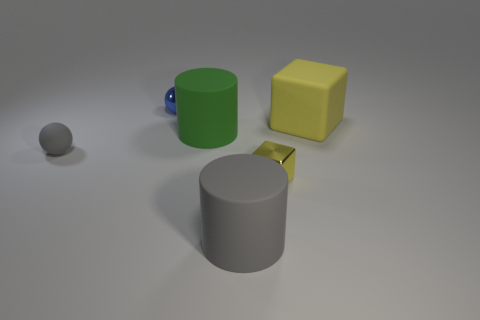Does the gray thing in front of the small block have the same material as the cylinder that is behind the small gray object?
Provide a short and direct response. Yes. There is a big thing that is the same color as the rubber sphere; what is its shape?
Your answer should be very brief. Cylinder. What number of objects are yellow shiny blocks that are to the left of the matte block or matte objects behind the gray sphere?
Your response must be concise. 3. There is a ball in front of the big green rubber cylinder; does it have the same color as the rubber thing in front of the small rubber sphere?
Offer a terse response. Yes. There is a thing that is both on the right side of the gray matte cylinder and in front of the matte ball; what is its shape?
Offer a very short reply. Cube. There is another ball that is the same size as the gray rubber ball; what is its color?
Offer a very short reply. Blue. Is there a tiny sphere of the same color as the tiny cube?
Your answer should be compact. No. Do the yellow thing in front of the small gray matte object and the gray thing that is to the left of the blue shiny sphere have the same size?
Offer a terse response. Yes. What is the material of the object that is in front of the small gray thing and behind the large gray matte cylinder?
Keep it short and to the point. Metal. What is the size of the rubber cylinder that is the same color as the small matte sphere?
Make the answer very short. Large. 